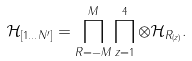Convert formula to latex. <formula><loc_0><loc_0><loc_500><loc_500>\mathcal { H } _ { [ 1 \dots N ^ { \prime } ] } = \prod _ { R = - M } ^ { M } \prod _ { z = 1 } ^ { 4 } \otimes \mathcal { H } _ { R _ { ( z ) } } .</formula> 